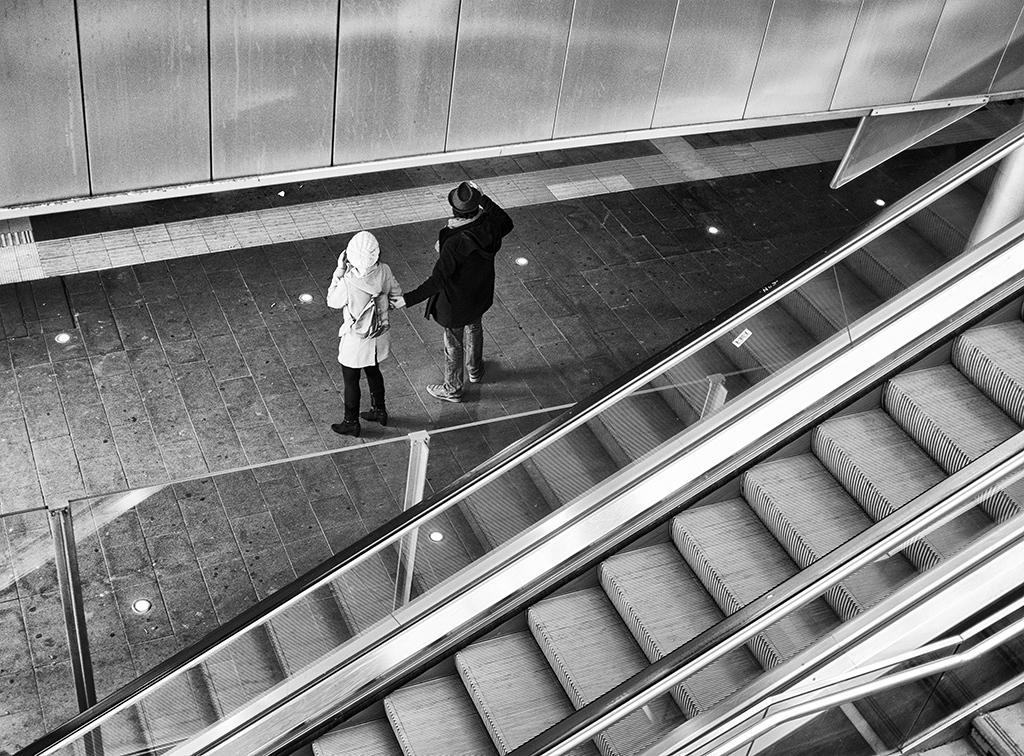How would you summarize this image in a sentence or two? This is a black and white picture, in this image we can see two people standing, there are some poles, staircase and the wall 